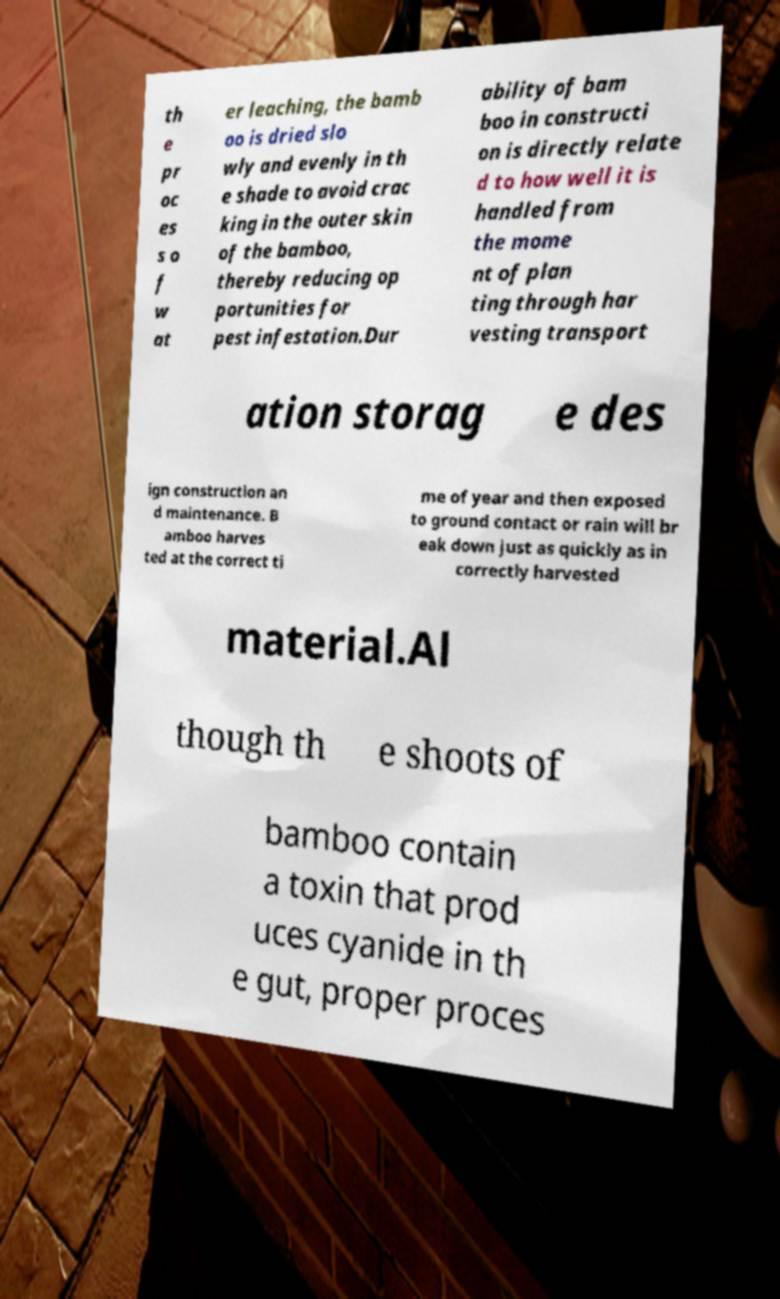Could you assist in decoding the text presented in this image and type it out clearly? th e pr oc es s o f w at er leaching, the bamb oo is dried slo wly and evenly in th e shade to avoid crac king in the outer skin of the bamboo, thereby reducing op portunities for pest infestation.Dur ability of bam boo in constructi on is directly relate d to how well it is handled from the mome nt of plan ting through har vesting transport ation storag e des ign construction an d maintenance. B amboo harves ted at the correct ti me of year and then exposed to ground contact or rain will br eak down just as quickly as in correctly harvested material.Al though th e shoots of bamboo contain a toxin that prod uces cyanide in th e gut, proper proces 